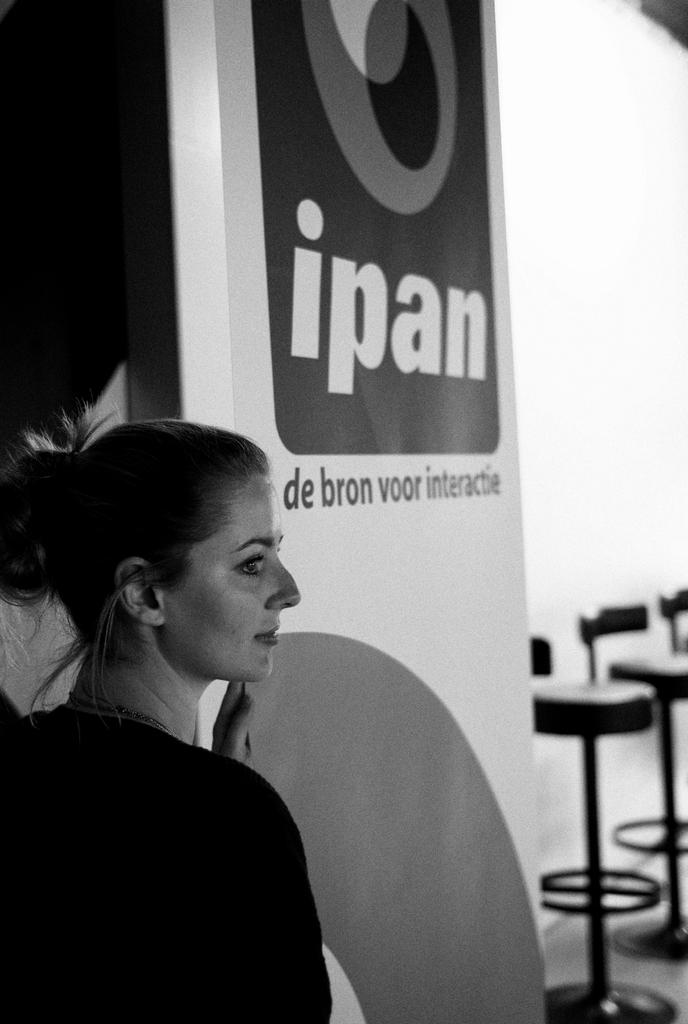What is the color scheme of the image? The image is black and white. Who is present in the image? There are women in the image. What else can be seen in the image besides the women? There is an advertisement and chairs in the image. What is the background of the image? There is a wall in the image. What type of wound can be seen on the woman's arm in the image? There is no wound visible on any woman's arm in the image. Can you read the letter that the woman is holding in the image? There is no letter present in the image. 